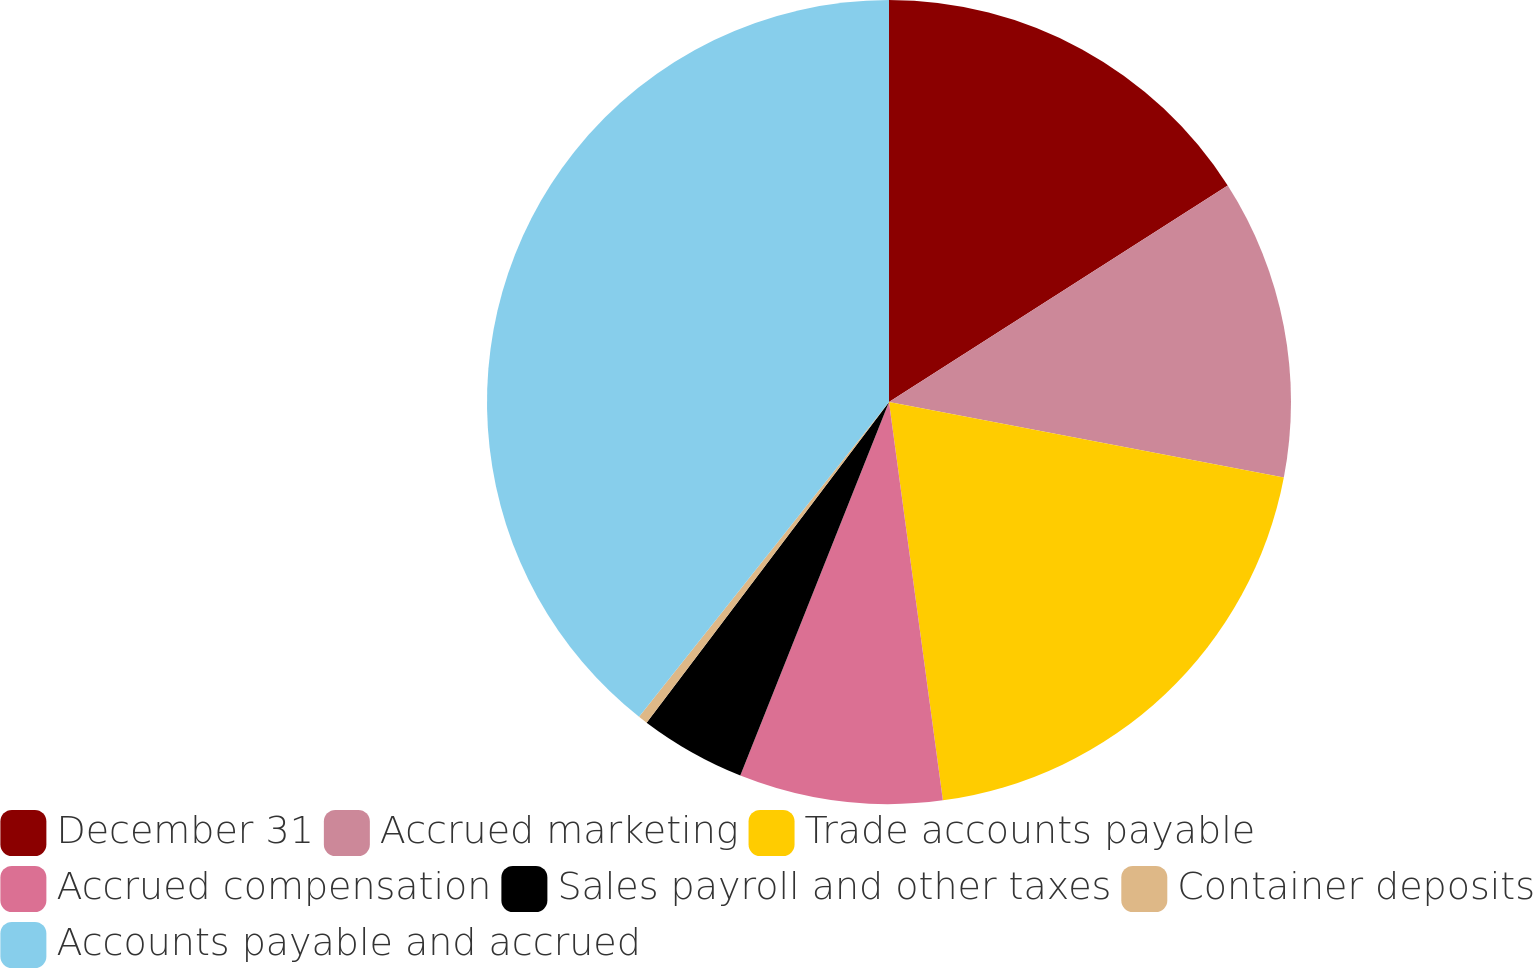Convert chart to OTSL. <chart><loc_0><loc_0><loc_500><loc_500><pie_chart><fcel>December 31<fcel>Accrued marketing<fcel>Trade accounts payable<fcel>Accrued compensation<fcel>Sales payroll and other taxes<fcel>Container deposits<fcel>Accounts payable and accrued<nl><fcel>15.95%<fcel>12.06%<fcel>19.85%<fcel>8.17%<fcel>4.27%<fcel>0.38%<fcel>39.32%<nl></chart> 